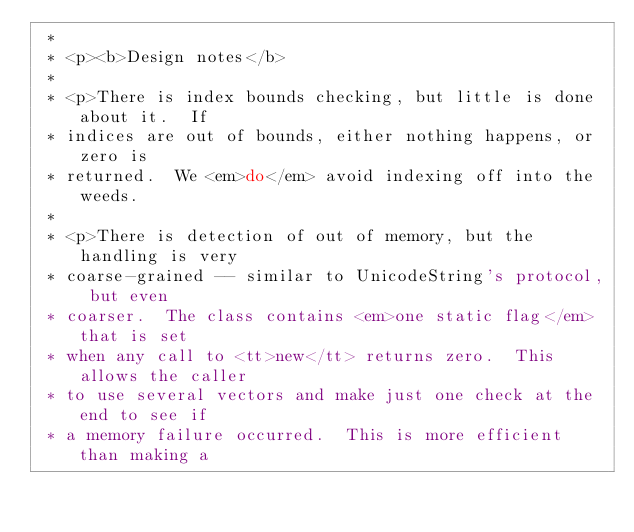Convert code to text. <code><loc_0><loc_0><loc_500><loc_500><_C_> *
 * <p><b>Design notes</b>
 *
 * <p>There is index bounds checking, but little is done about it.  If
 * indices are out of bounds, either nothing happens, or zero is
 * returned.  We <em>do</em> avoid indexing off into the weeds.
 *
 * <p>There is detection of out of memory, but the handling is very
 * coarse-grained -- similar to UnicodeString's protocol, but even
 * coarser.  The class contains <em>one static flag</em> that is set
 * when any call to <tt>new</tt> returns zero.  This allows the caller
 * to use several vectors and make just one check at the end to see if
 * a memory failure occurred.  This is more efficient than making a</code> 